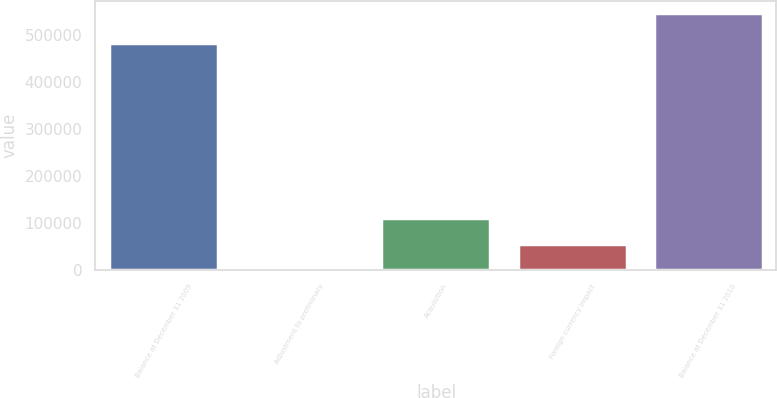Convert chart. <chart><loc_0><loc_0><loc_500><loc_500><bar_chart><fcel>Balance at December 31 2009<fcel>Adjustment to preliminary<fcel>Acquisition<fcel>Foreign currency impact<fcel>Balance at December 31 2010<nl><fcel>482978<fcel>585<fcel>109634<fcel>55109.7<fcel>545832<nl></chart> 